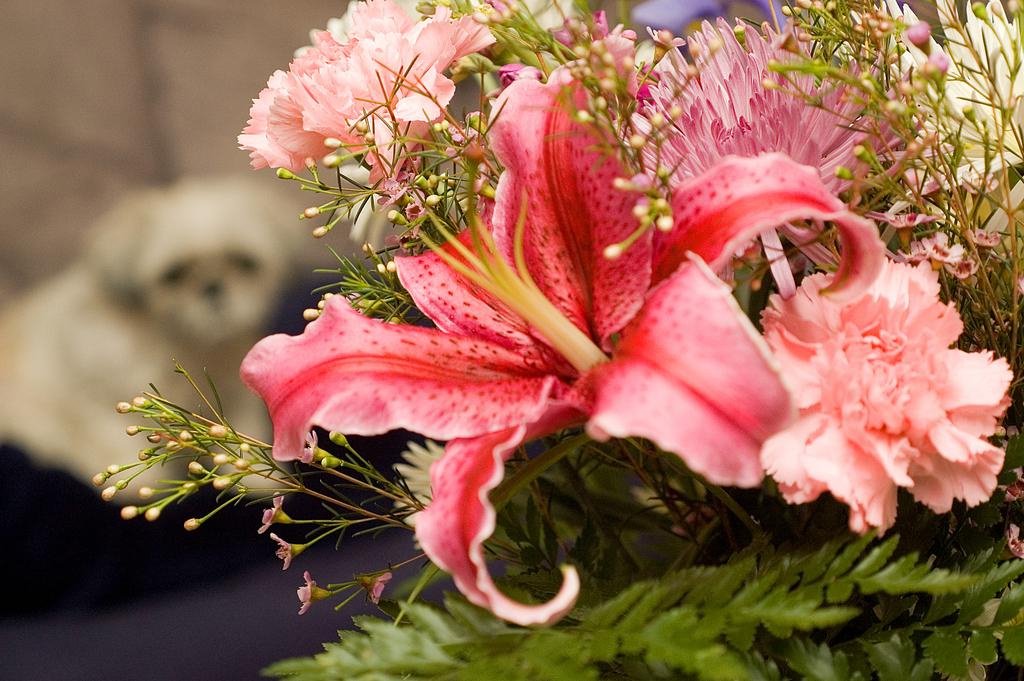What type of flowers can be seen in the image? There are pink color flowers in the image. What else is present in the image besides the flowers? There are leaves in the image. Can you describe the animal on the left side of the image? There appears to be a dog on the left side of the image. What type of lace can be seen on the dog's collar in the image? There is no lace or collar visible on the dog in the image. How does the zephyr affect the flowers in the image? There is no mention of a zephyr or any wind in the image, so its effect on the flowers cannot be determined. 